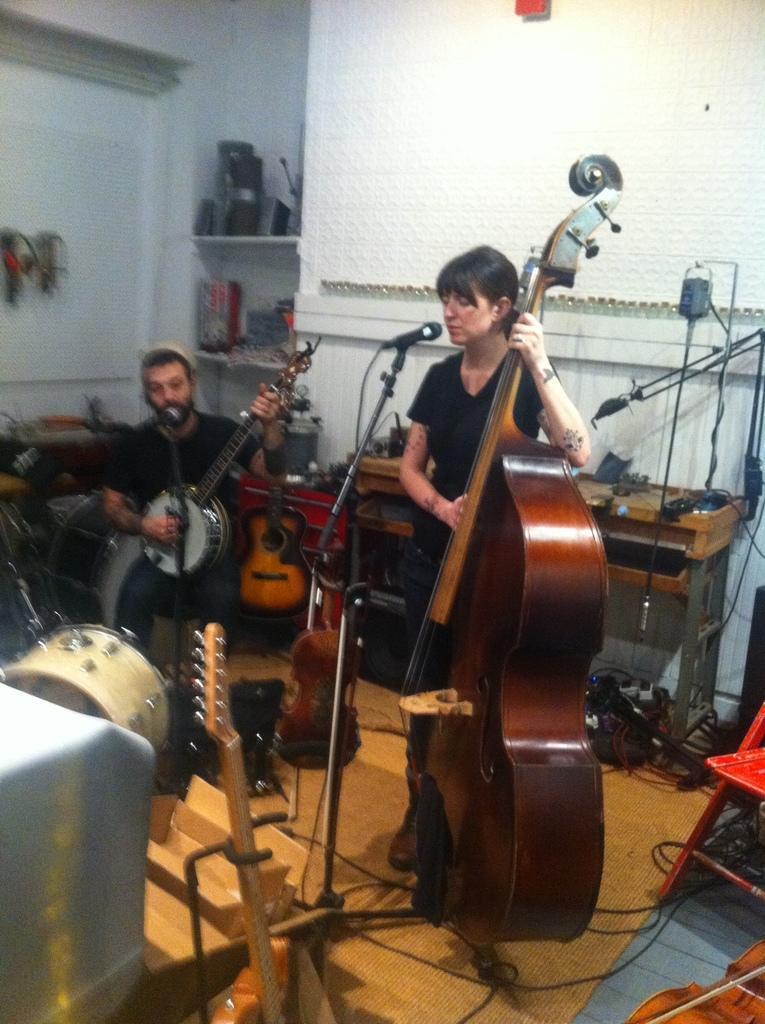Describe this image in one or two sentences. There is a woman standing, singing and playing a cello. There is a mic and stand in front of this woman. Beside her, there is a man sitting and playing guitar. In the background, there is a wall and some objects on the desk. On the right hand side, there is a chair. On the left hand side, there is a drum, guitar and some object. 